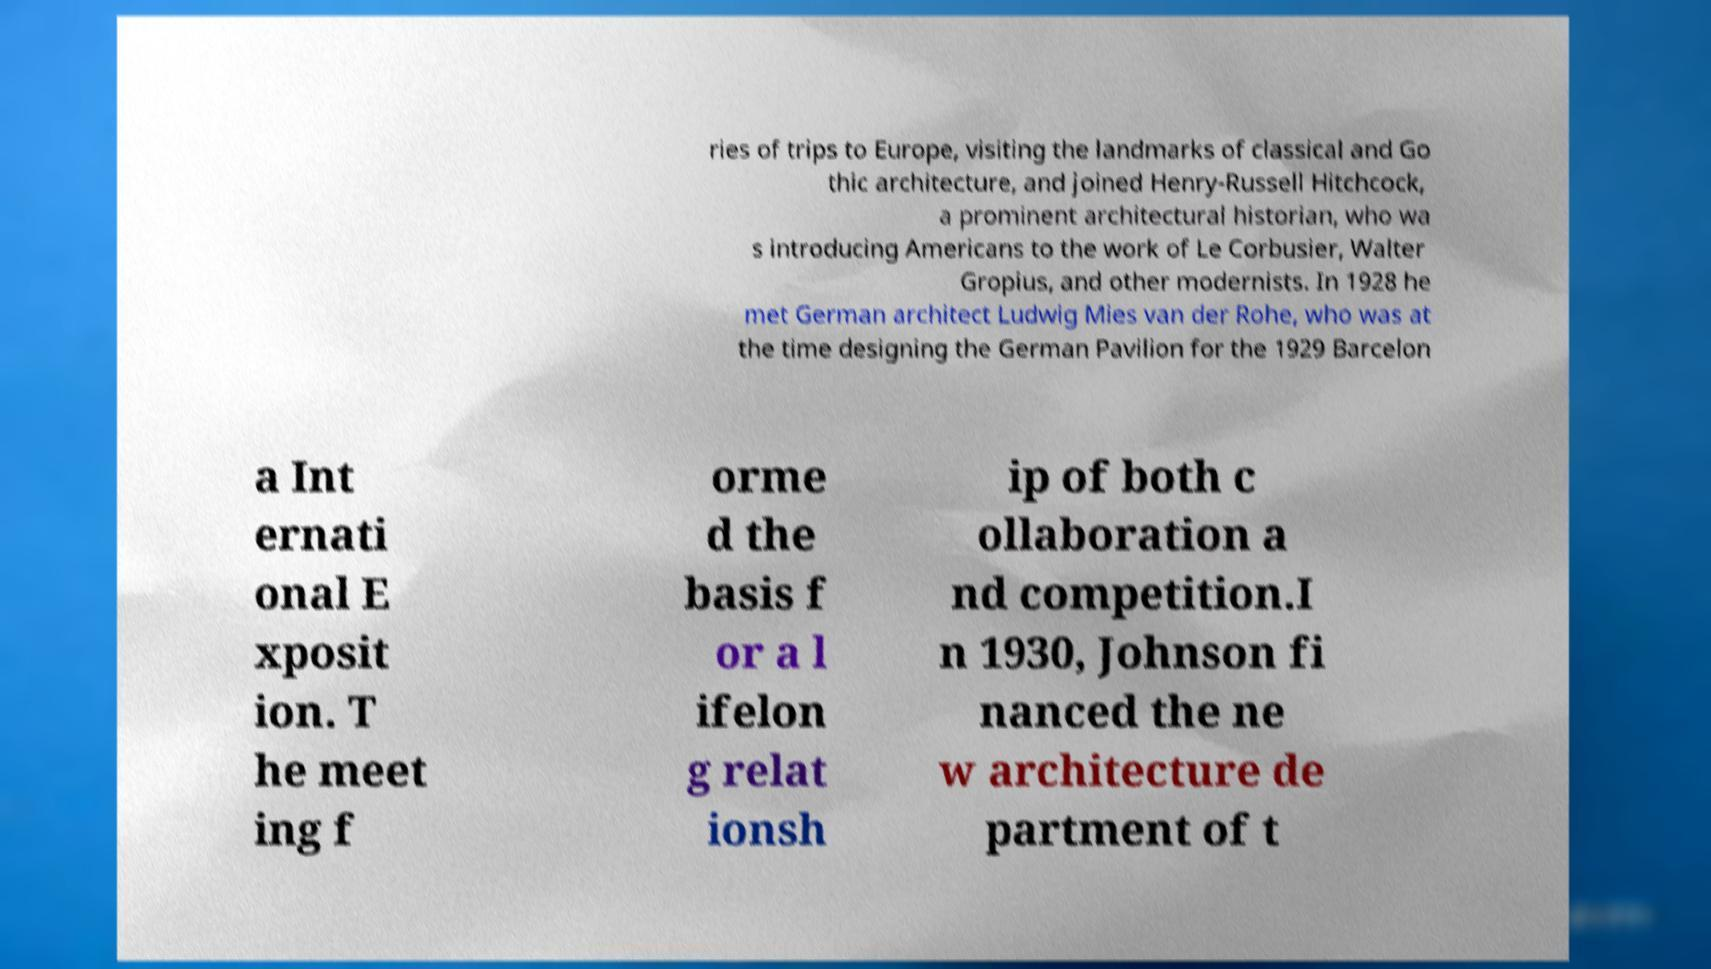What messages or text are displayed in this image? I need them in a readable, typed format. ries of trips to Europe, visiting the landmarks of classical and Go thic architecture, and joined Henry-Russell Hitchcock, a prominent architectural historian, who wa s introducing Americans to the work of Le Corbusier, Walter Gropius, and other modernists. In 1928 he met German architect Ludwig Mies van der Rohe, who was at the time designing the German Pavilion for the 1929 Barcelon a Int ernati onal E xposit ion. T he meet ing f orme d the basis f or a l ifelon g relat ionsh ip of both c ollaboration a nd competition.I n 1930, Johnson fi nanced the ne w architecture de partment of t 